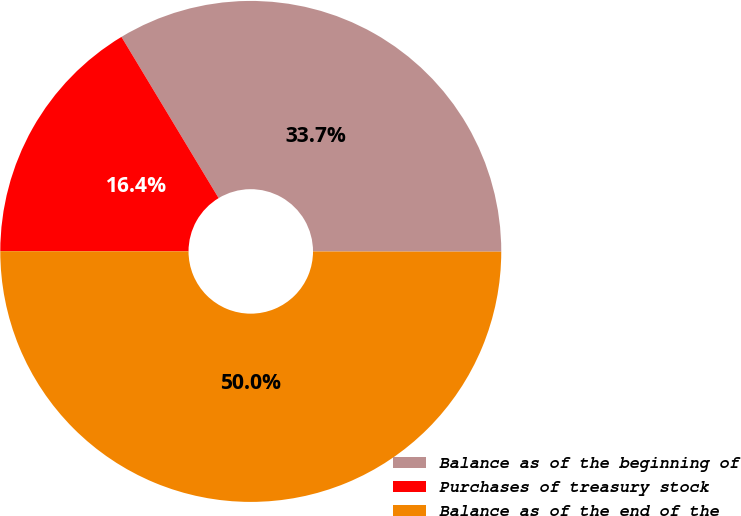Convert chart to OTSL. <chart><loc_0><loc_0><loc_500><loc_500><pie_chart><fcel>Balance as of the beginning of<fcel>Purchases of treasury stock<fcel>Balance as of the end of the<nl><fcel>33.65%<fcel>16.35%<fcel>50.0%<nl></chart> 